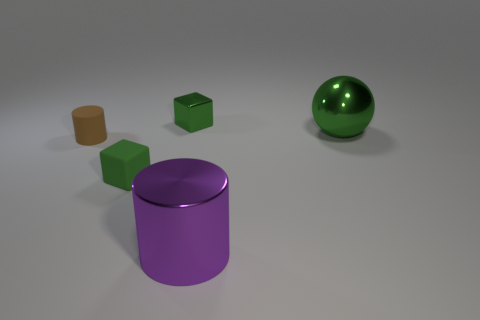What number of other things are the same shape as the small shiny object?
Give a very brief answer. 1. How many spheres have the same material as the brown cylinder?
Keep it short and to the point. 0. There is a green cube on the left side of the tiny green object that is behind the brown cylinder; what is its size?
Your response must be concise. Small. There is a metal object that is both behind the green rubber block and to the left of the large green thing; what is its color?
Provide a short and direct response. Green. Is the shape of the big green thing the same as the brown object?
Offer a very short reply. No. There is a matte object that is the same color as the small metal cube; what is its size?
Ensure brevity in your answer.  Small. There is a small matte thing that is in front of the cylinder that is behind the green matte thing; what shape is it?
Give a very brief answer. Cube. There is a purple shiny thing; does it have the same shape as the green shiny thing that is to the left of the big purple cylinder?
Your response must be concise. No. There is a metallic cylinder that is the same size as the sphere; what is its color?
Ensure brevity in your answer.  Purple. Are there fewer metal spheres that are in front of the ball than tiny blocks left of the big purple shiny cylinder?
Provide a succinct answer. Yes. 